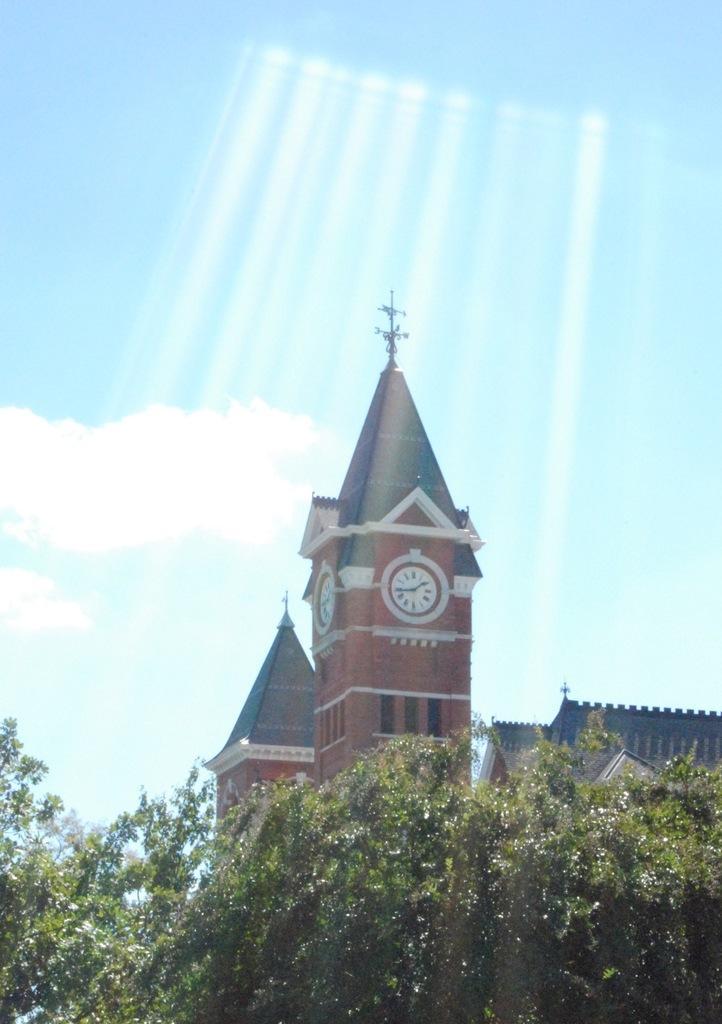In one or two sentences, can you explain what this image depicts? In this image we can see buildings and a building with clock, there are trees in front of the building and sky with clouds in the background. 